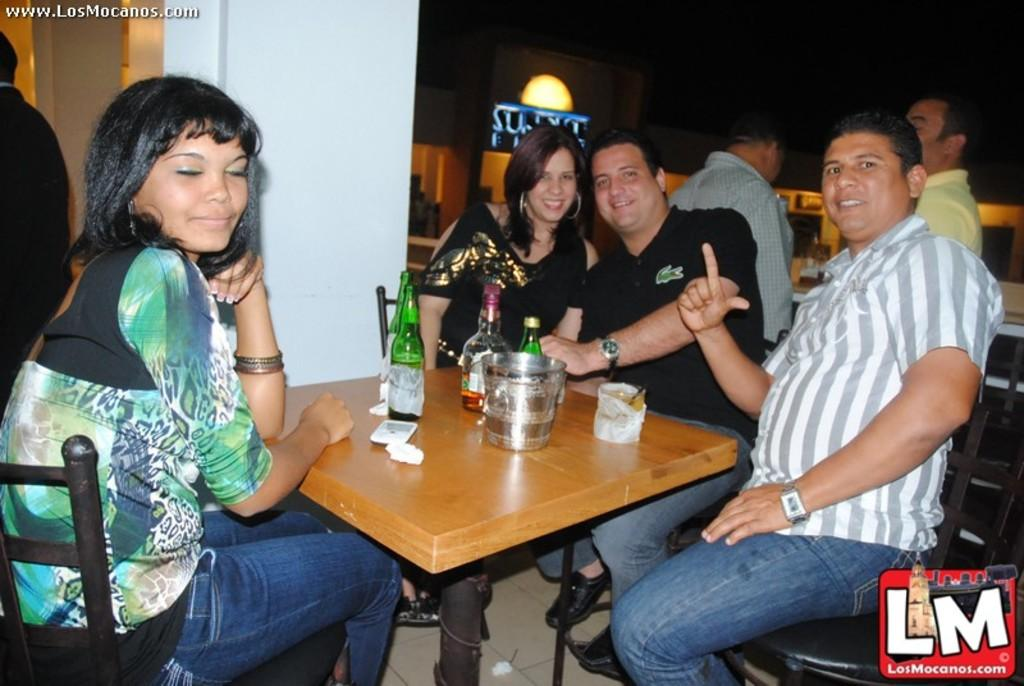How many people are in the image? There is a group of people in the image. What are some of the people doing in the image? Some people are seated on chairs. What objects are in front of the seated people? There are bottles, a bowl, and glasses in front of the seated people. What is on the table in the image? There is a mobile on the table. Can you hear the sound of water in the image? There is no reference to water or any sounds in the image, so it's not possible to determine if you can hear the sound of water. 